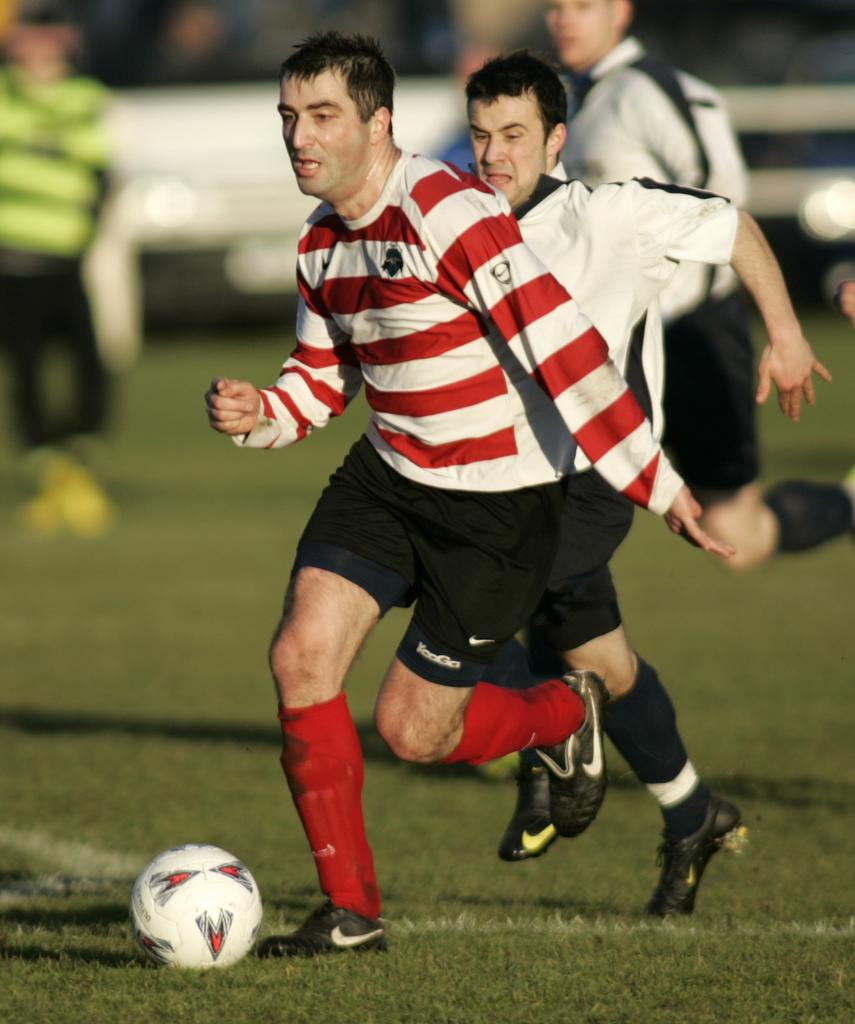What are the men in the image doing? The men in the image are playing with a ball. What type of surface can be seen in the image? There is grass in the image. What type of cannon is being used by the men in the image? There is no cannon present in the image; the men are playing with a ball. What kind of seed is being planted in the image? There is no seed being planted in the image; the men are playing with a ball on a grassy surface. 